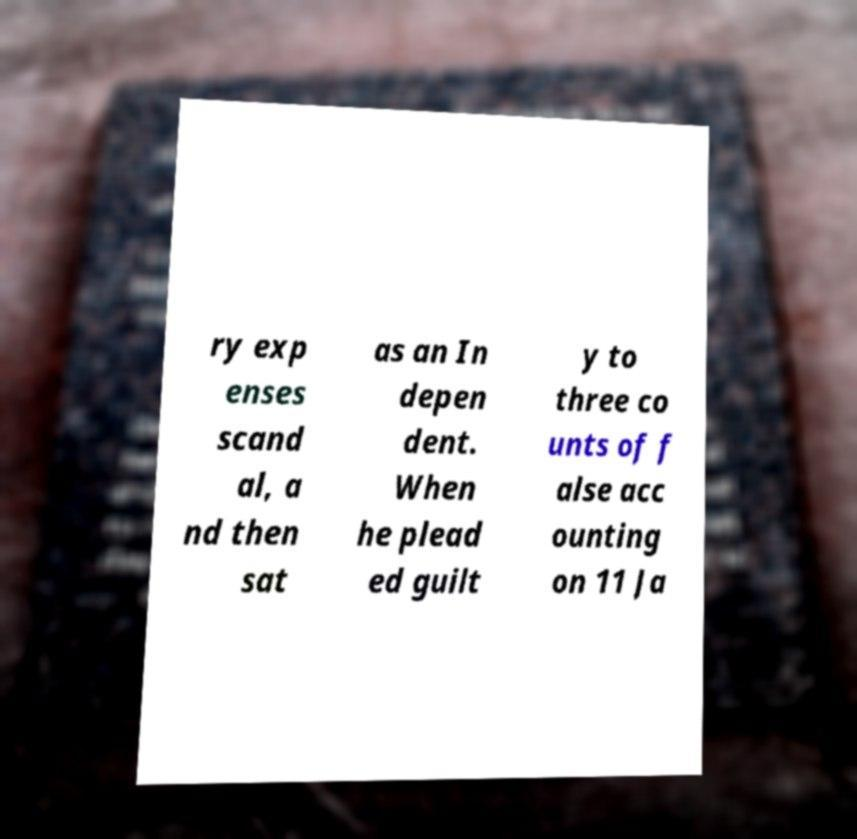Please read and relay the text visible in this image. What does it say? ry exp enses scand al, a nd then sat as an In depen dent. When he plead ed guilt y to three co unts of f alse acc ounting on 11 Ja 